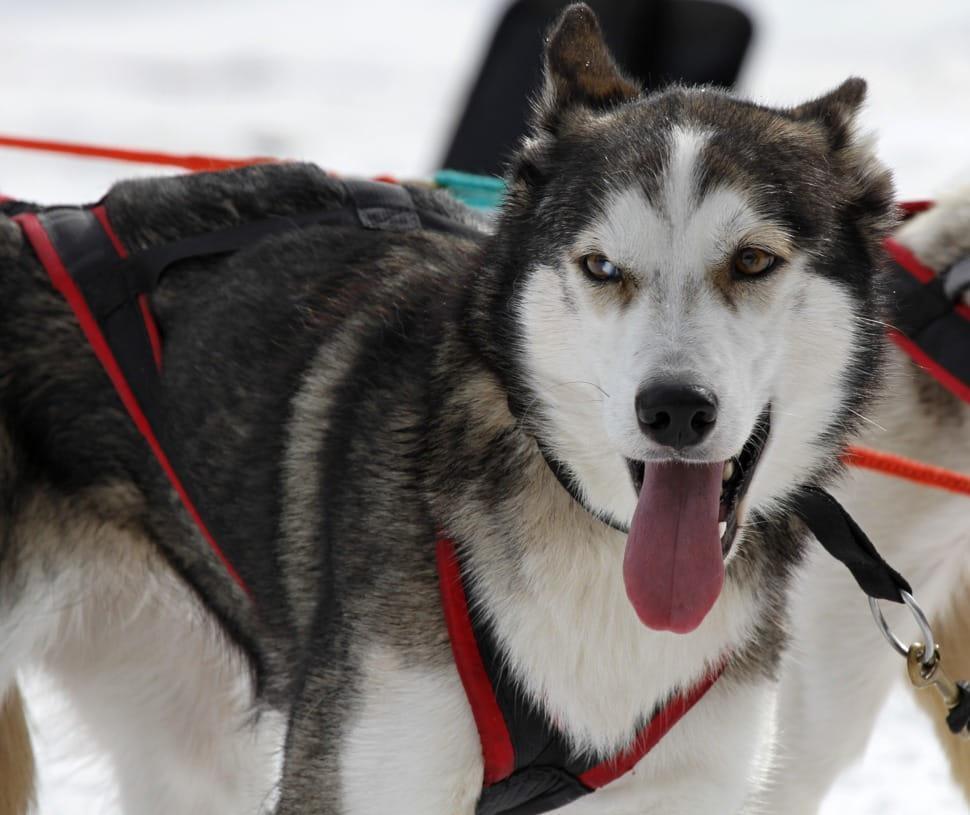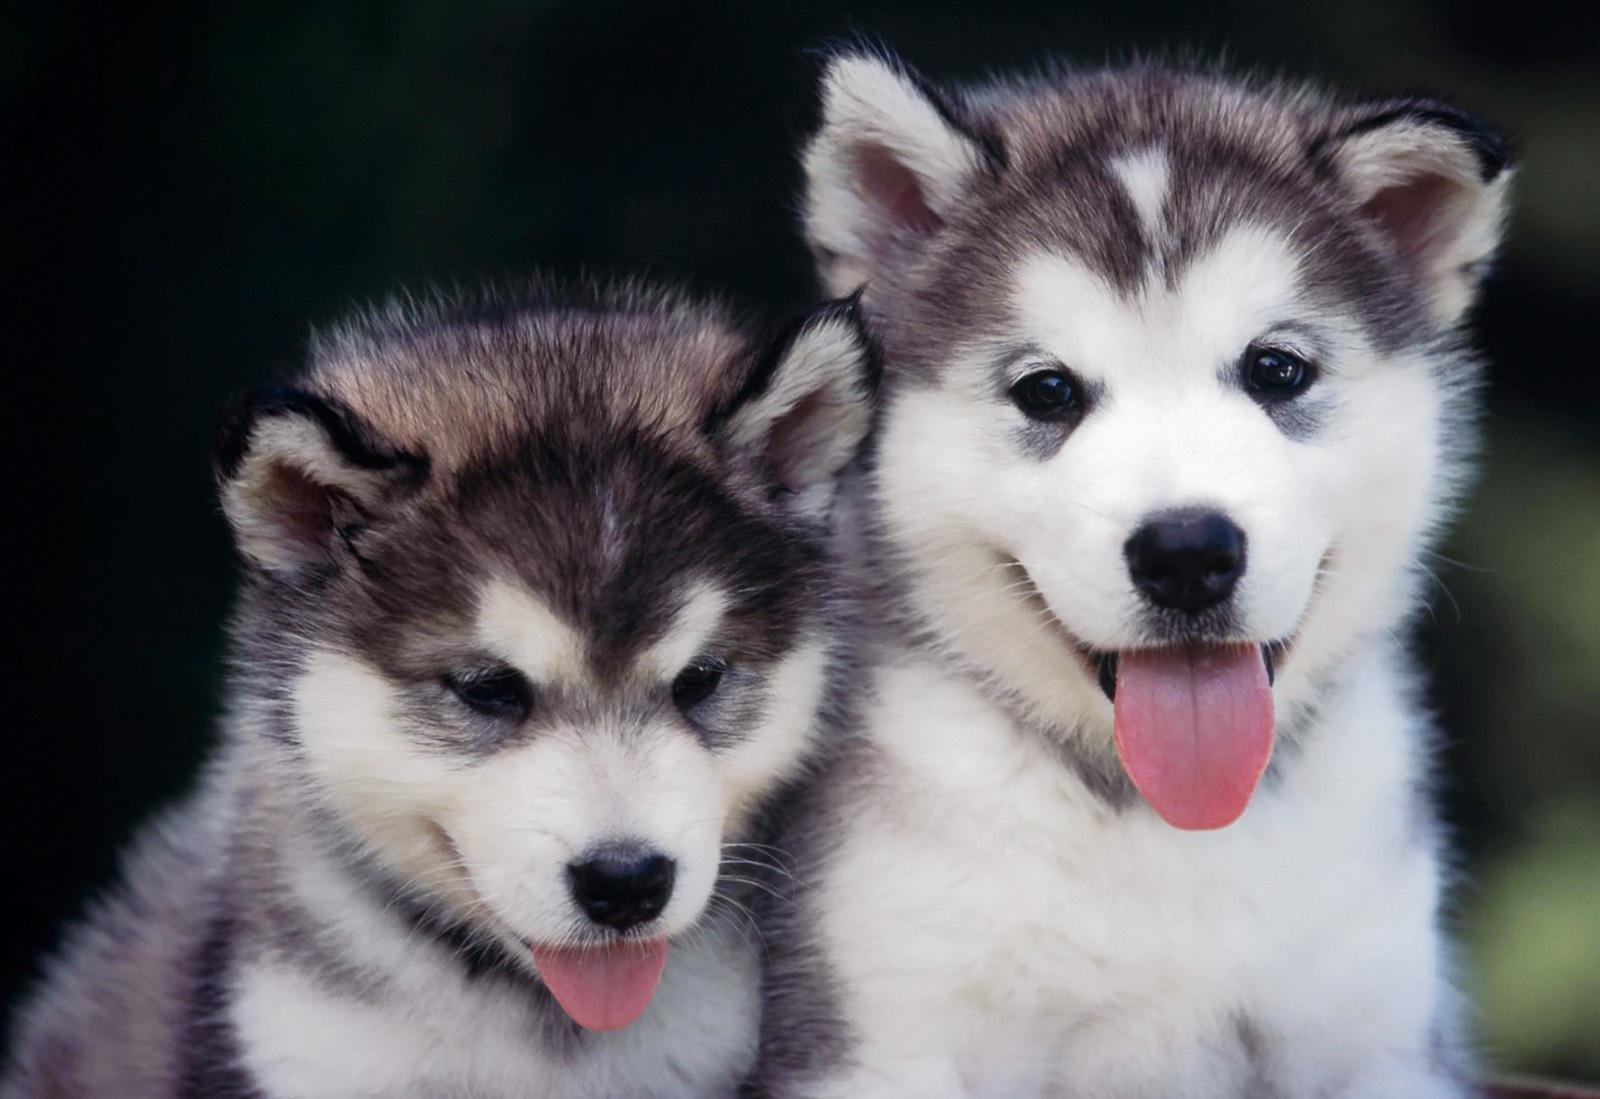The first image is the image on the left, the second image is the image on the right. Considering the images on both sides, is "The right image shows two husky dogs of similar age and size, posed with their heads side-by-side, showing similar expressions." valid? Answer yes or no. Yes. The first image is the image on the left, the second image is the image on the right. For the images shown, is this caption "The right image contains exactly two dogs." true? Answer yes or no. Yes. 